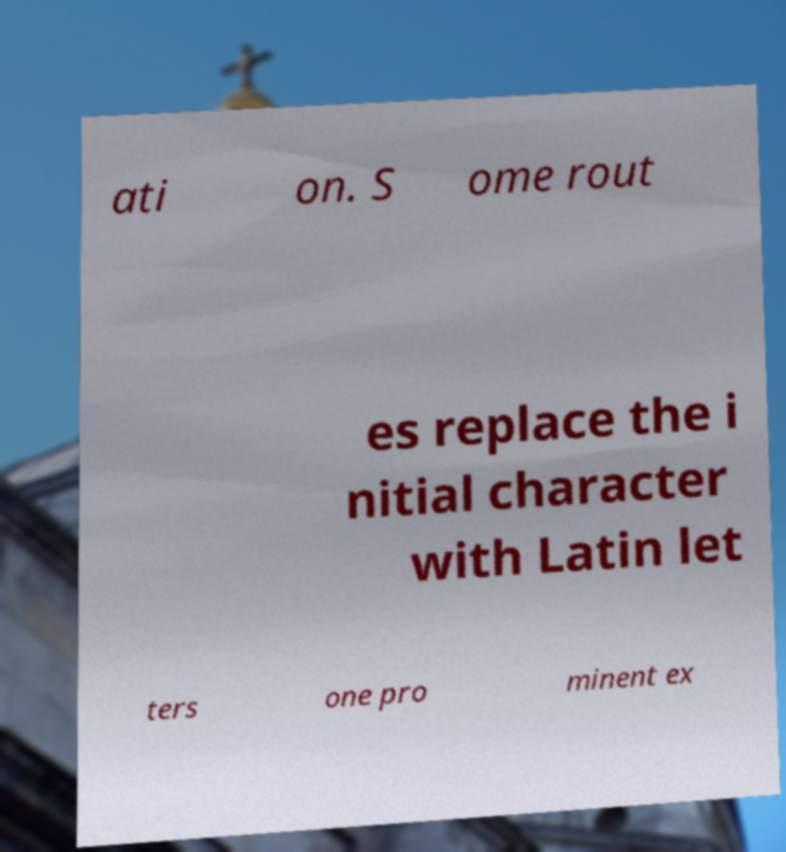There's text embedded in this image that I need extracted. Can you transcribe it verbatim? ati on. S ome rout es replace the i nitial character with Latin let ters one pro minent ex 